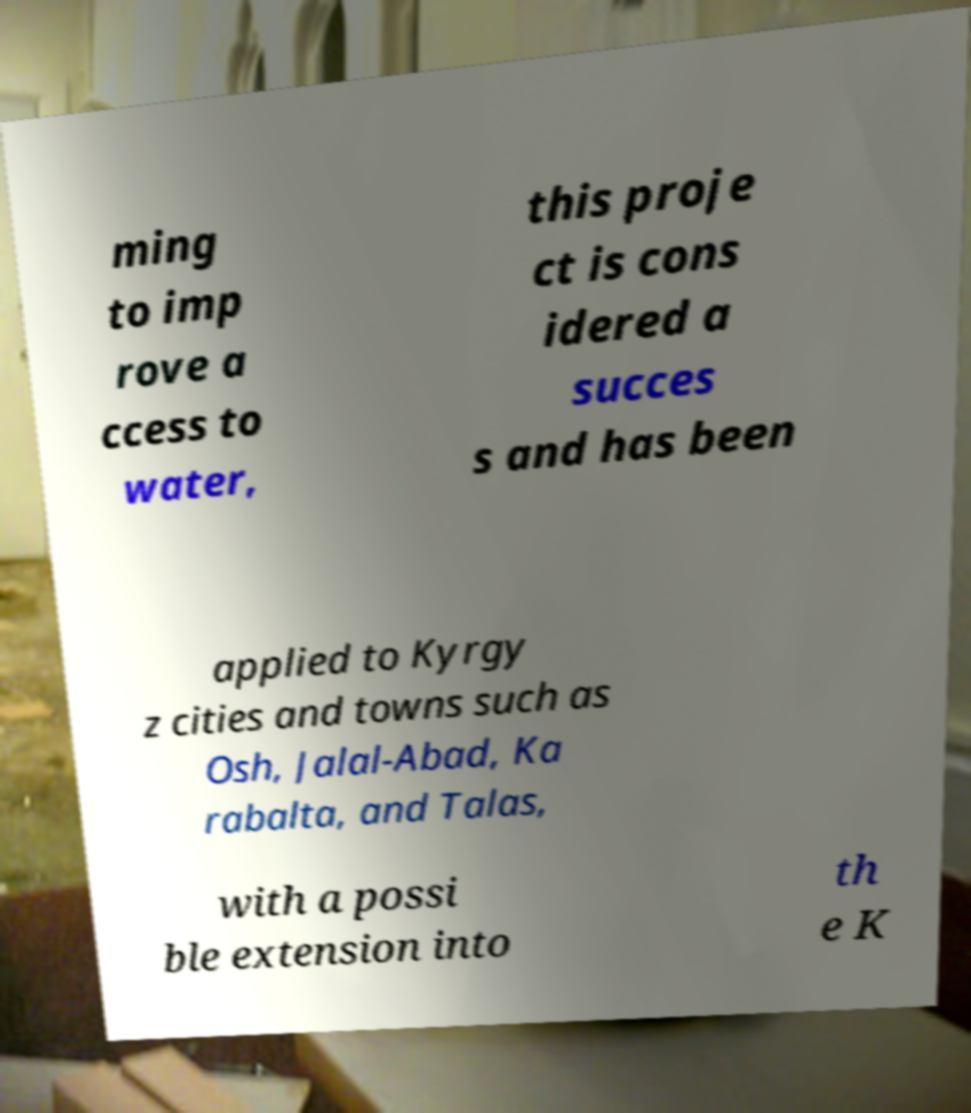Could you assist in decoding the text presented in this image and type it out clearly? ming to imp rove a ccess to water, this proje ct is cons idered a succes s and has been applied to Kyrgy z cities and towns such as Osh, Jalal-Abad, Ka rabalta, and Talas, with a possi ble extension into th e K 